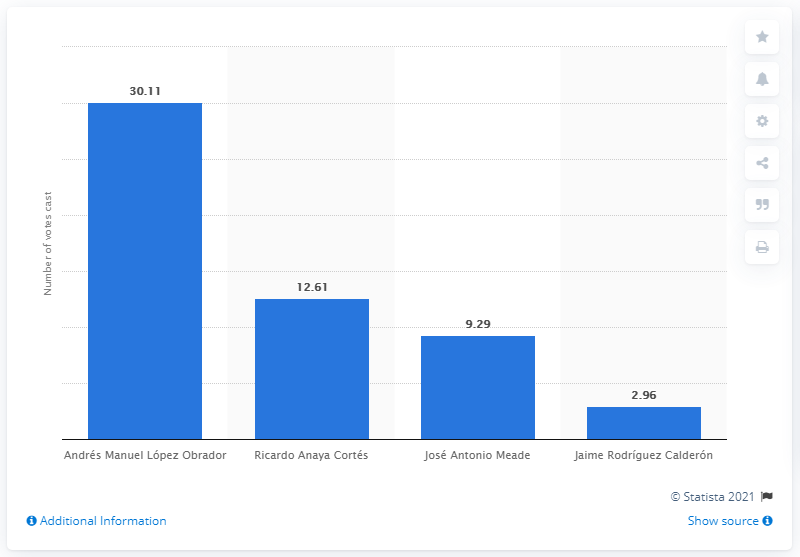Outline some significant characteristics in this image. Andrés Manuel López Obrador received 30.11 votes in the election. 